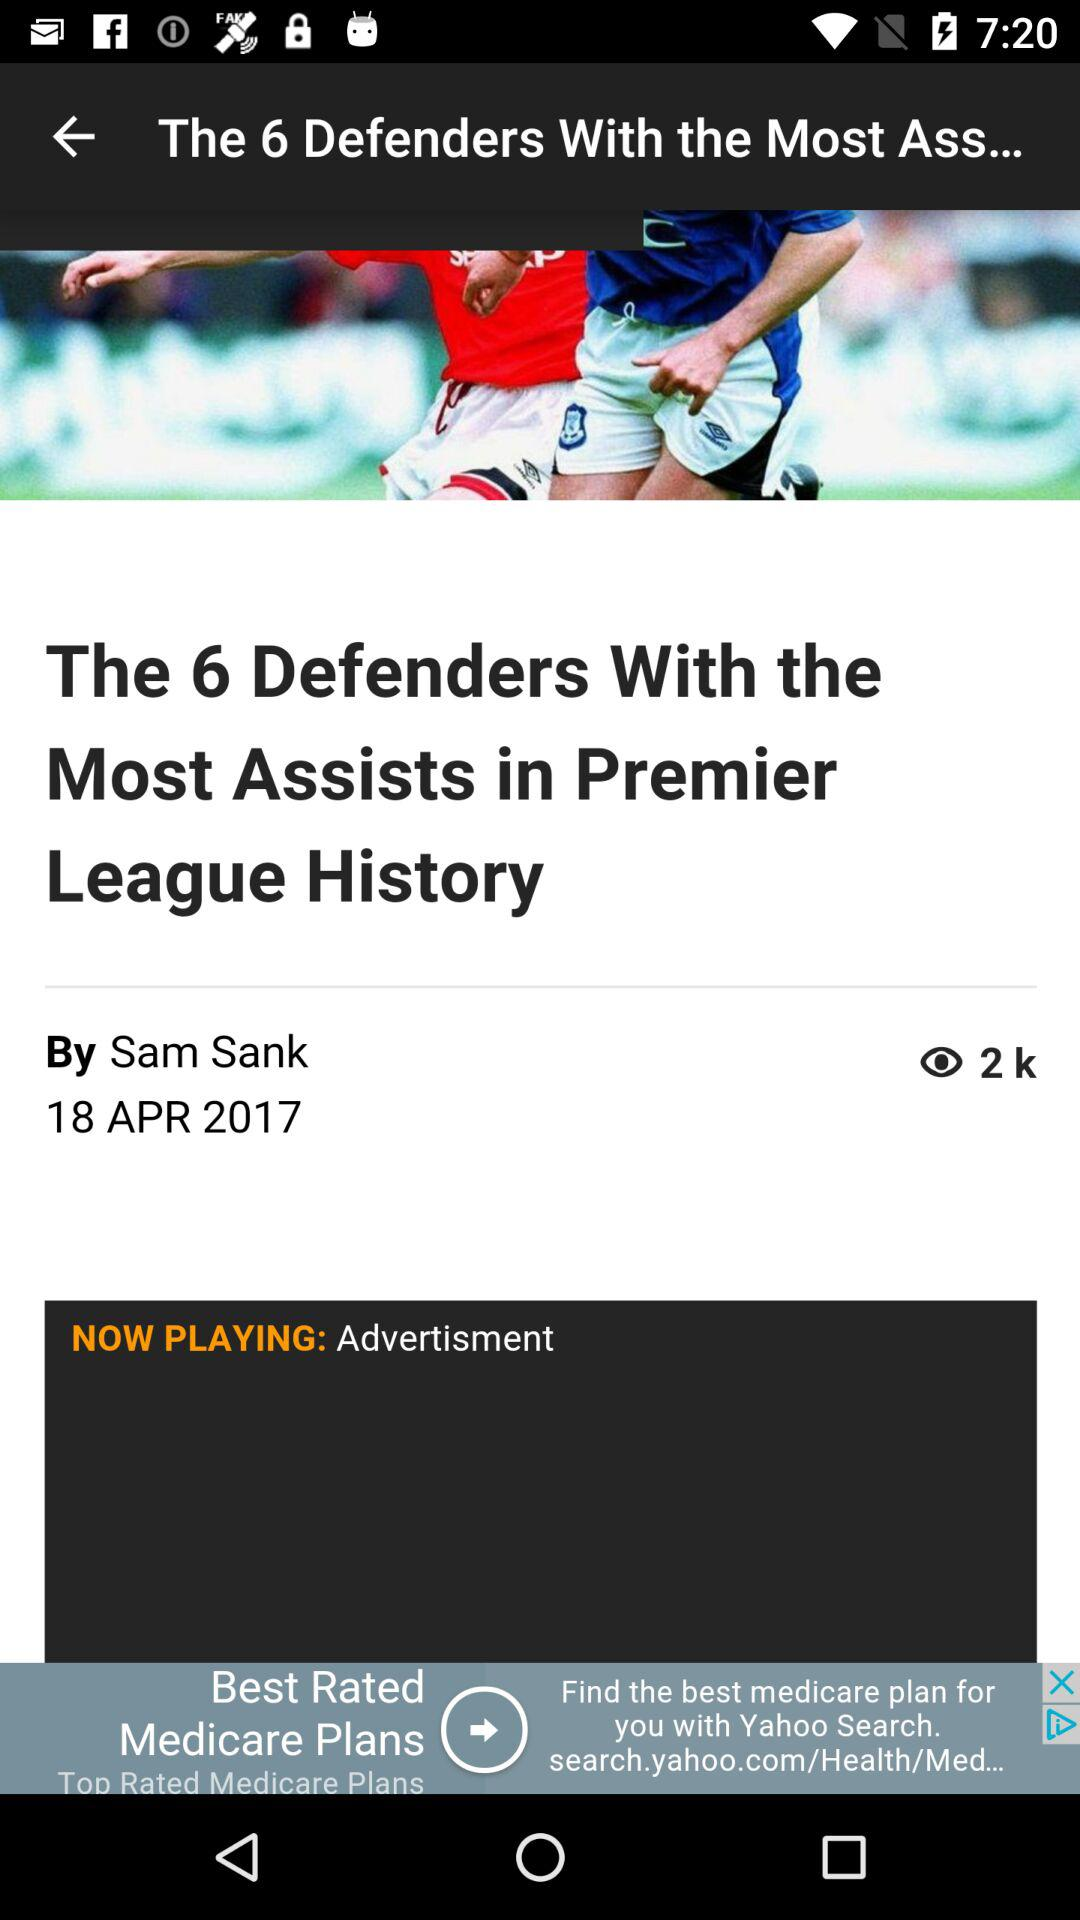How many people viewed the article? The number of people who have viewed the article is 2k. 